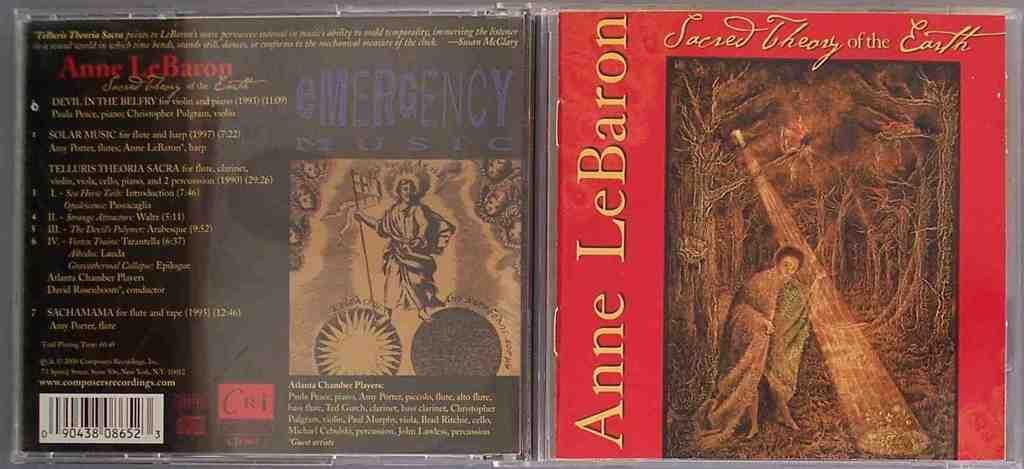<image>
Give a short and clear explanation of the subsequent image. An Anne LeBaron CD has a red background and a painting of a man. 